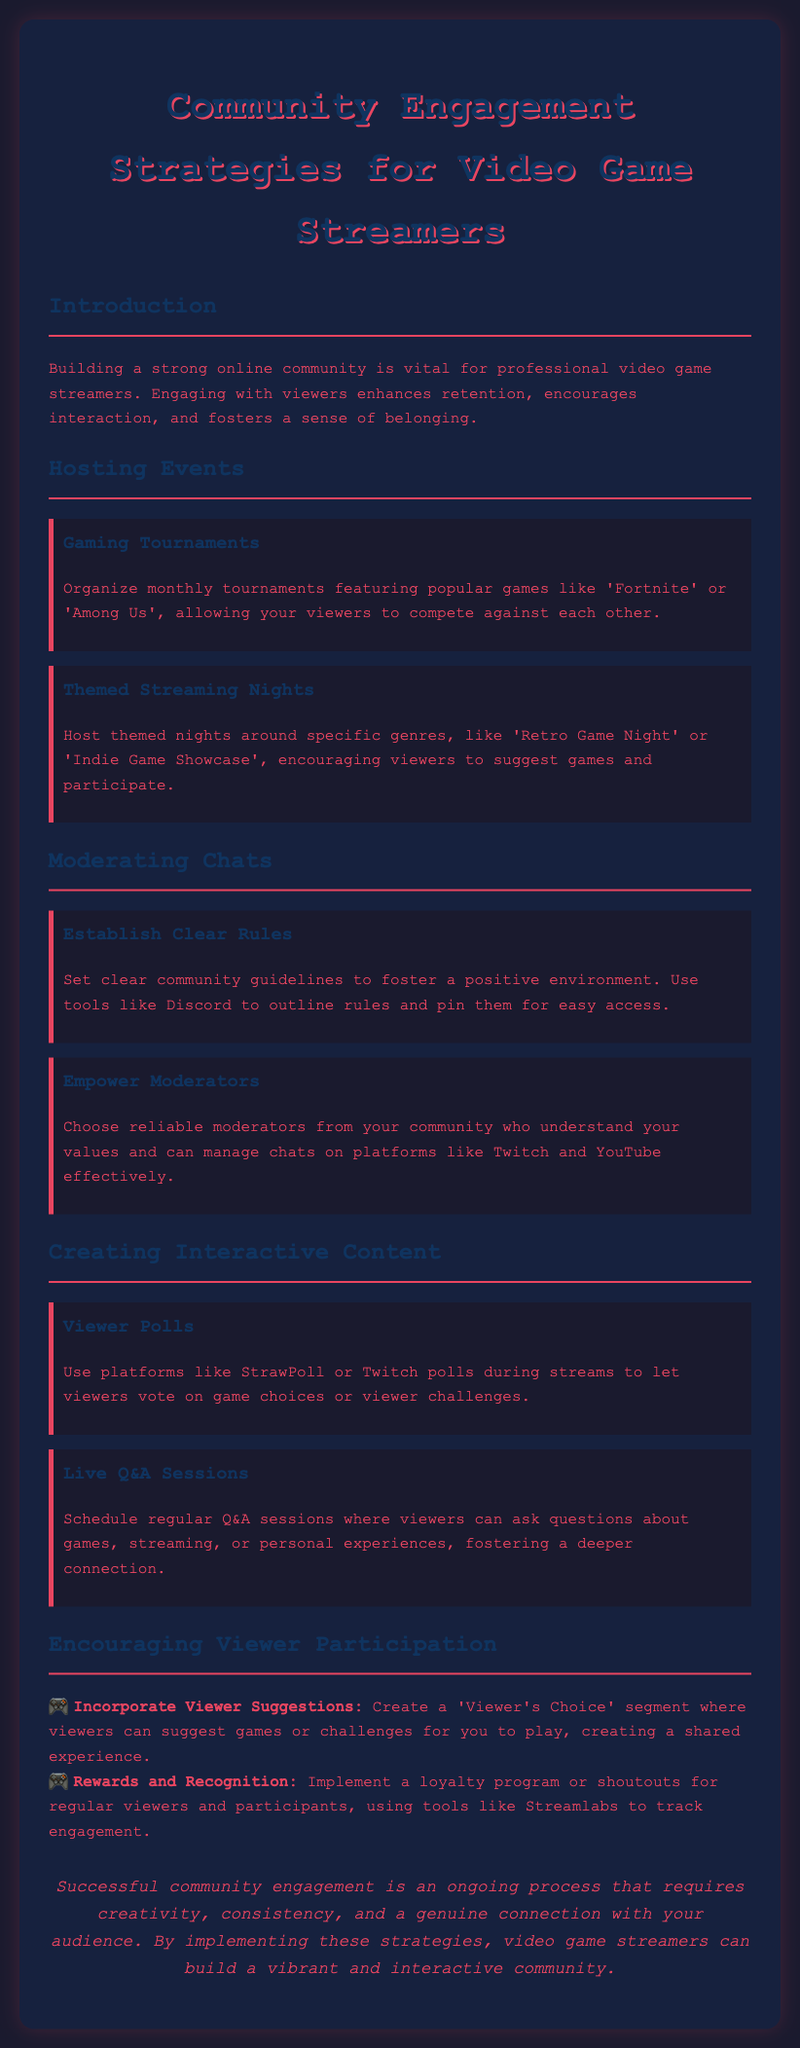What is the title of the document? The title of the document is provided in the header as "Community Engagement Strategies for Video Game Streamers."
Answer: Community Engagement Strategies for Video Game Streamers How often should gaming tournaments be organized? The document states that monthly tournaments should be organized.
Answer: Monthly What are two types of themed nights mentioned? The document lists "Retro Game Night" and "Indie Game Showcase" as examples of themed nights.
Answer: Retro Game Night, Indie Game Showcase What is one tool mentioned for establishing community rules? The document suggests using Discord as a tool to outline and pin community guidelines for easy access.
Answer: Discord What is one method for fostering viewer participation? One method mentioned is to create a "Viewer's Choice" segment for suggesting games or challenges to play.
Answer: Viewer’s Choice Which platform is recommended for conducting viewer polls? The document recommends using StrawPoll or Twitch polls for viewer polls during streams.
Answer: StrawPoll, Twitch polls How should moderators be selected according to the document? The document advises choosing reliable moderators from the community who understand the streamer's values.
Answer: Reliable moderators What should be implemented for regular viewers and participants? The document mentions implementing a loyalty program or shoutouts for regular viewers to encourage participation.
Answer: Loyalty program 